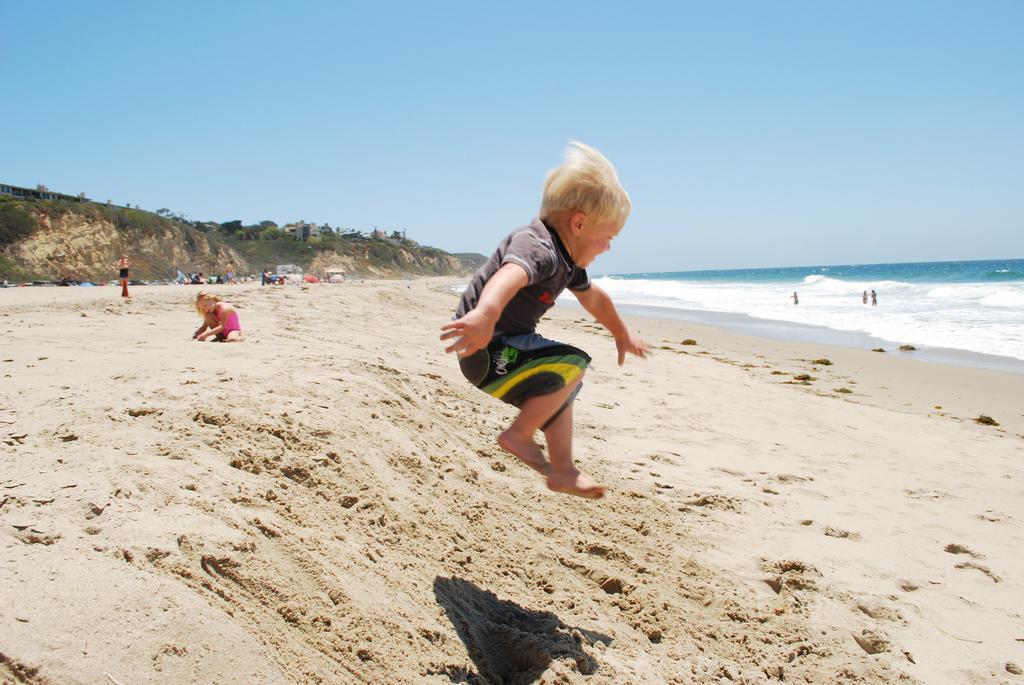Describe this image in one or two sentences. This picture describes about group of people, few are on the sand and few are in the water, in the middle of the image we can see a boy, he is jumping, in the background we can see few trees. 